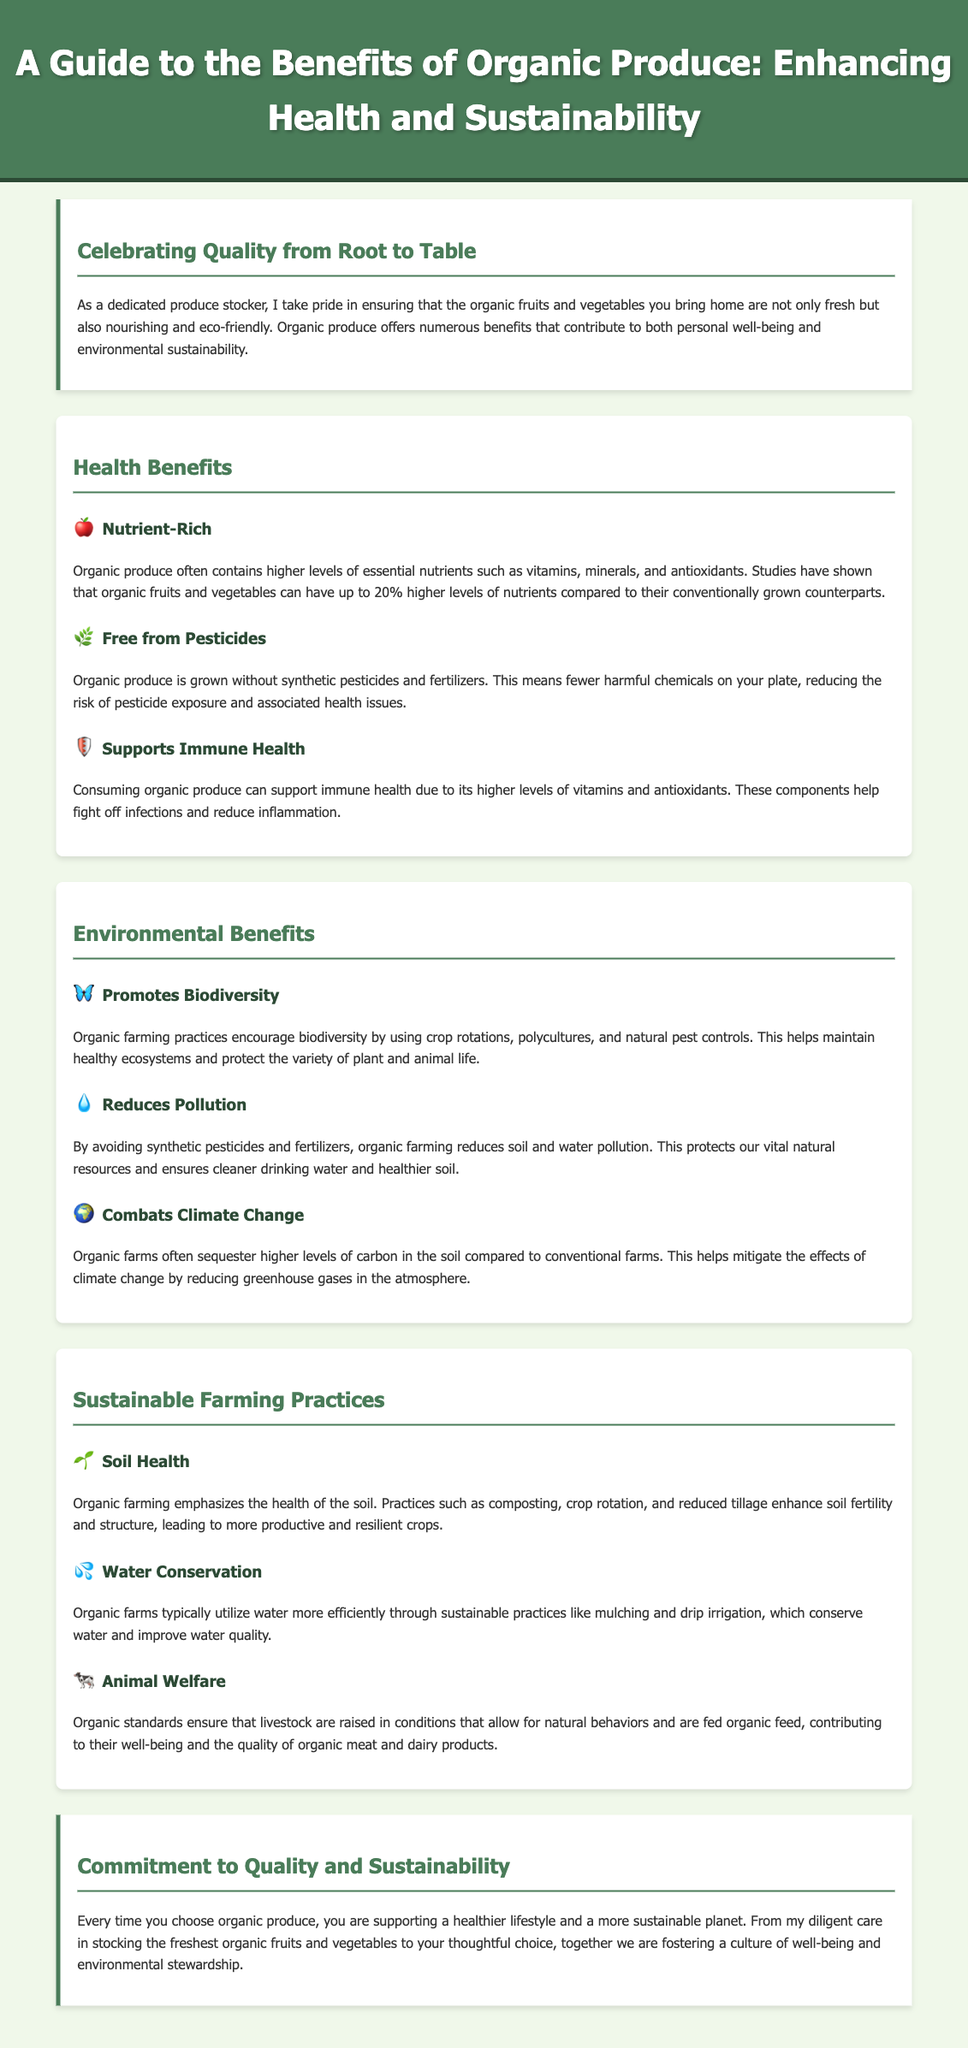What is the main theme of the guide? The main theme emphasizes the benefits of choosing organic produce for health and sustainability.
Answer: Health and Sustainability How much higher can organic produce nutrients be compared to conventional? The document states that organic fruits and vegetables can have up to 20% higher levels of nutrients compared to their conventionally grown counterparts.
Answer: 20% What is a key health benefit of consuming organic produce? A key health benefit highlighted in the document is its support for immune health due to higher levels of vitamins and antioxidants.
Answer: Supports Immune Health What farming practice promotes biodiversity? The document mentions crop rotations, polycultures, and natural pest controls as practices that encourage biodiversity.
Answer: Crop Rotations How do organic farms contribute to climate change mitigation? Organic farms are stated to sequester higher levels of carbon in the soil, which helps mitigate climate change effects.
Answer: Sequester Carbon What is emphasized as crucial for organic farming? Soil health is emphasized as a crucial aspect in organic farming, focusing on enhancing soil fertility and structure.
Answer: Soil Health What sustainable practice improves water quality on organic farms? The document notes that organic farms utilize practices like mulching and drip irrigation to conserve water and improve quality.
Answer: Mulching and Drip Irrigation What role does animal welfare play in organic farming? Organic standards ensure that livestock are raised under conditions that allow for natural behaviors, contributing to their well-being.
Answer: Natural Behaviors What is the concluding commitment of the guide? The concluding commitment emphasizes supporting a healthier lifestyle and a more sustainable planet through organic produce choices.
Answer: Healthier Lifestyle and Sustainable Planet 